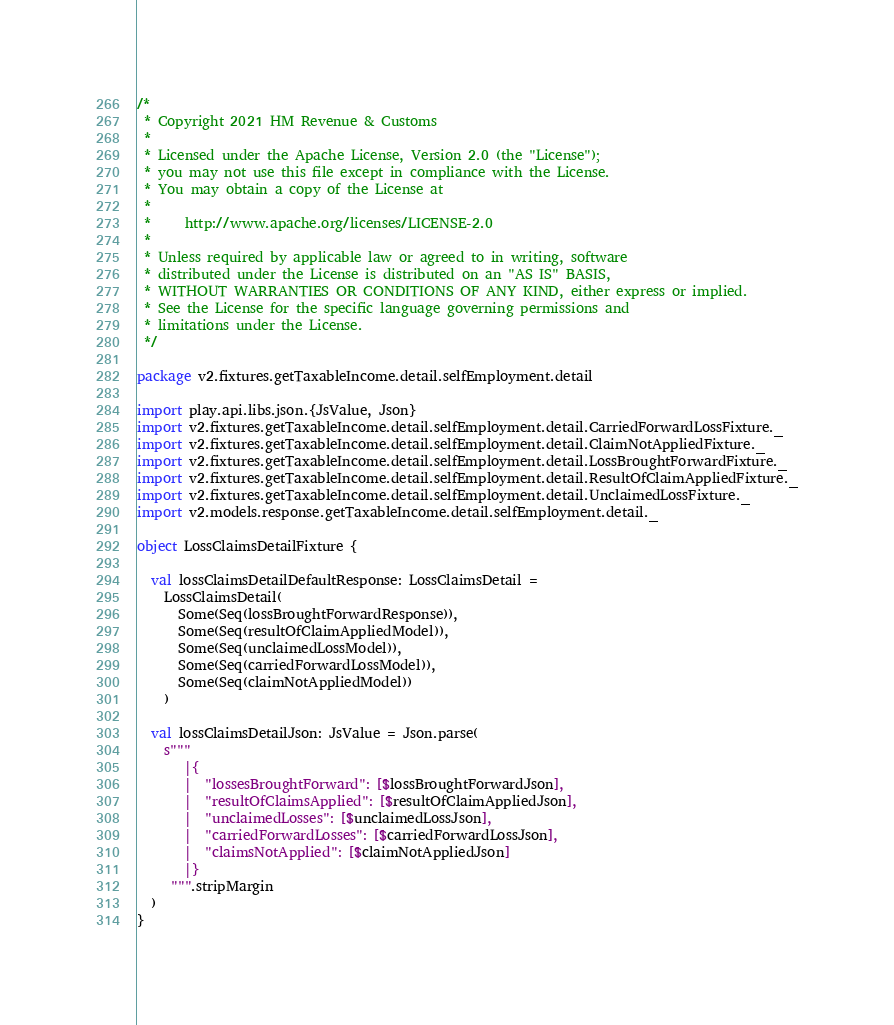<code> <loc_0><loc_0><loc_500><loc_500><_Scala_>/*
 * Copyright 2021 HM Revenue & Customs
 *
 * Licensed under the Apache License, Version 2.0 (the "License");
 * you may not use this file except in compliance with the License.
 * You may obtain a copy of the License at
 *
 *     http://www.apache.org/licenses/LICENSE-2.0
 *
 * Unless required by applicable law or agreed to in writing, software
 * distributed under the License is distributed on an "AS IS" BASIS,
 * WITHOUT WARRANTIES OR CONDITIONS OF ANY KIND, either express or implied.
 * See the License for the specific language governing permissions and
 * limitations under the License.
 */

package v2.fixtures.getTaxableIncome.detail.selfEmployment.detail

import play.api.libs.json.{JsValue, Json}
import v2.fixtures.getTaxableIncome.detail.selfEmployment.detail.CarriedForwardLossFixture._
import v2.fixtures.getTaxableIncome.detail.selfEmployment.detail.ClaimNotAppliedFixture._
import v2.fixtures.getTaxableIncome.detail.selfEmployment.detail.LossBroughtForwardFixture._
import v2.fixtures.getTaxableIncome.detail.selfEmployment.detail.ResultOfClaimAppliedFixture._
import v2.fixtures.getTaxableIncome.detail.selfEmployment.detail.UnclaimedLossFixture._
import v2.models.response.getTaxableIncome.detail.selfEmployment.detail._

object LossClaimsDetailFixture {

  val lossClaimsDetailDefaultResponse: LossClaimsDetail =
    LossClaimsDetail(
      Some(Seq(lossBroughtForwardResponse)),
      Some(Seq(resultOfClaimAppliedModel)),
      Some(Seq(unclaimedLossModel)),
      Some(Seq(carriedForwardLossModel)),
      Some(Seq(claimNotAppliedModel))
    )

  val lossClaimsDetailJson: JsValue = Json.parse(
    s"""
       |{
       |  "lossesBroughtForward": [$lossBroughtForwardJson],
       |  "resultOfClaimsApplied": [$resultOfClaimAppliedJson],
       |  "unclaimedLosses": [$unclaimedLossJson],
       |  "carriedForwardLosses": [$carriedForwardLossJson],
       |  "claimsNotApplied": [$claimNotAppliedJson]
       |}
     """.stripMargin
  )
}</code> 